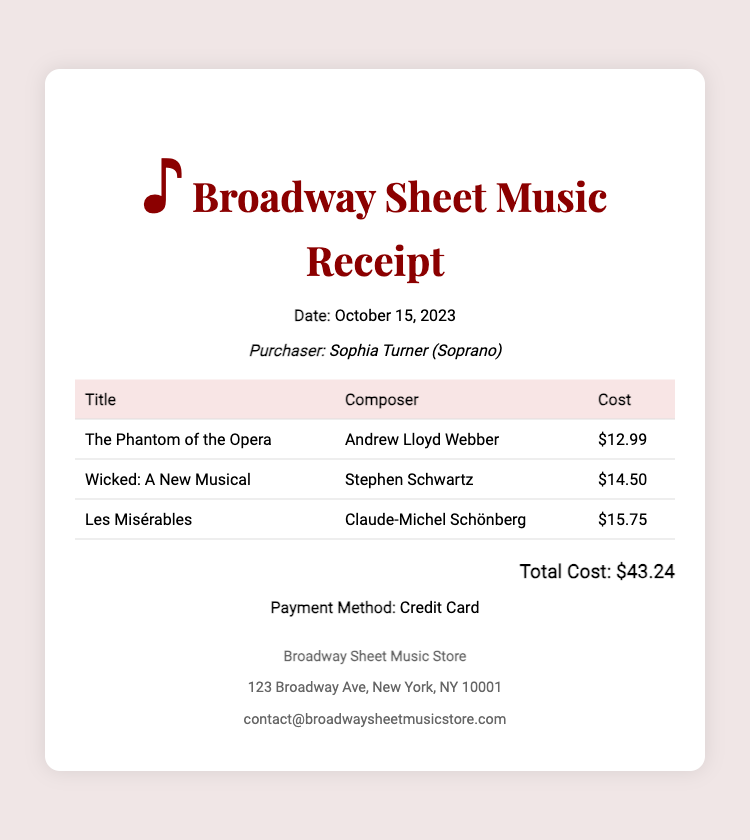What is the date of the transaction? The date of the transaction is explicitly mentioned in the document under the "Date" heading.
Answer: October 15, 2023 Who is the purchaser listed in the receipt? The purchaser's name is presented prominently in the document after the "Purchaser" label.
Answer: Sophia Turner What is the title of the first music piece purchased? The title of the first music piece can be found in the first row of the table under the "Title" column.
Answer: The Phantom of the Opera How much did the sheet music for Wicked cost? The cost of Wicked is stated in the second row of the table, next to its title.
Answer: $14.50 What is the total cost of all the sheet music? The total cost is calculated and presented separately, indicating the sum of all individual costs.
Answer: $43.24 Who is the composer of Les Misérables? The composer's name for Les Misérables is listed in the table next to the title.
Answer: Claude-Michel Schönberg What payment method was used for this transaction? The payment method is noted in the footer section of the document.
Answer: Credit Card How many music pieces were purchased in total? The total number of pieces is determined by counting the entries in the table.
Answer: 3 What is the name of the vendor? The vendor's name is included at the bottom of the receipt, representing the business that issued the receipt.
Answer: Broadway Sheet Music Store 